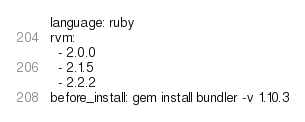<code> <loc_0><loc_0><loc_500><loc_500><_YAML_>language: ruby
rvm:
  - 2.0.0
  - 2.1.5
  - 2.2.2
before_install: gem install bundler -v 1.10.3
</code> 